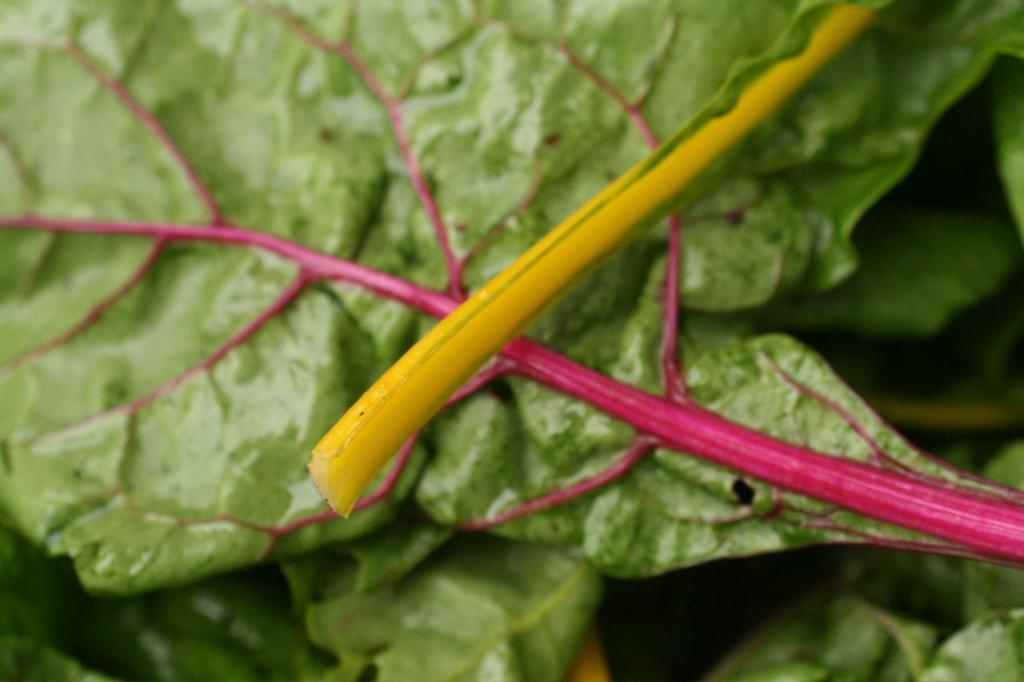What is the color of the twig in the image? The twig in the image is yellow. What is the twig resting on? The twig is on green color leaves. Are there any additional colors on the leaves? Yes, the green leaves have red lines on them. How many actors are performing on the twig in the image? There are no actors present in the image; it features a yellow twig on green leaves with red lines. 